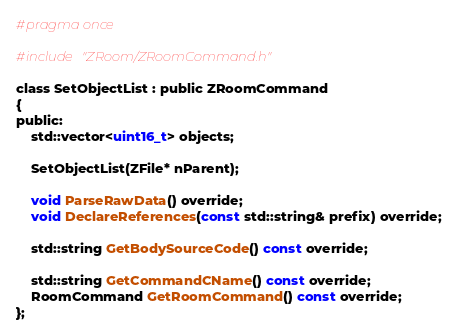Convert code to text. <code><loc_0><loc_0><loc_500><loc_500><_C_>#pragma once

#include "ZRoom/ZRoomCommand.h"

class SetObjectList : public ZRoomCommand
{
public:
	std::vector<uint16_t> objects;

	SetObjectList(ZFile* nParent);

	void ParseRawData() override;
	void DeclareReferences(const std::string& prefix) override;

	std::string GetBodySourceCode() const override;

	std::string GetCommandCName() const override;
	RoomCommand GetRoomCommand() const override;
};
</code> 